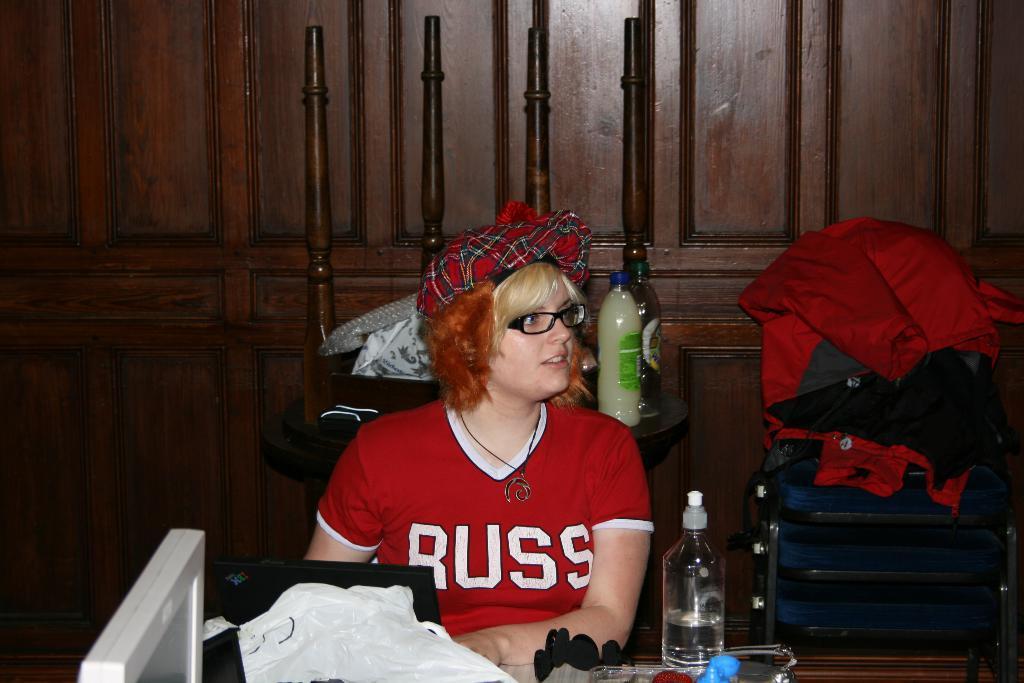In one or two sentences, can you explain what this image depicts? In this image we can see a lady with spectacles is sitting and in front and behind her there are tables which contains some objects on it, on the right side of the image there are stools one on the other and there are clothes on it. 